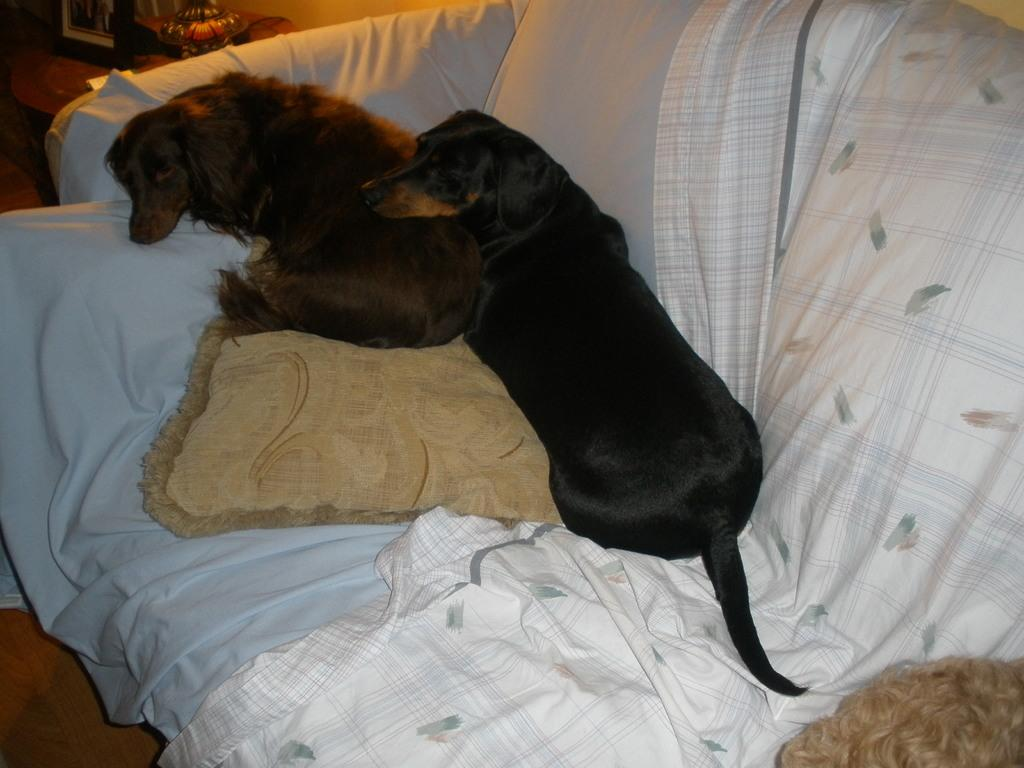How many dogs are on the couch in the image? There are two dogs on the couch in the image. What is on the couch besides the dogs? There is a pillow on the couch. What else can be seen in the image besides the couch and dogs? There are clothes visible in the image. What can be seen in the background of the image? There is a photo frame and other objects visible in the background. What type of toothpaste is the dog using in the image? There is no toothpaste present in the image, and the dogs are not using any toothpaste. Are the dogs fighting in the image? The dogs are not fighting in the image; they are both sitting on the couch. 